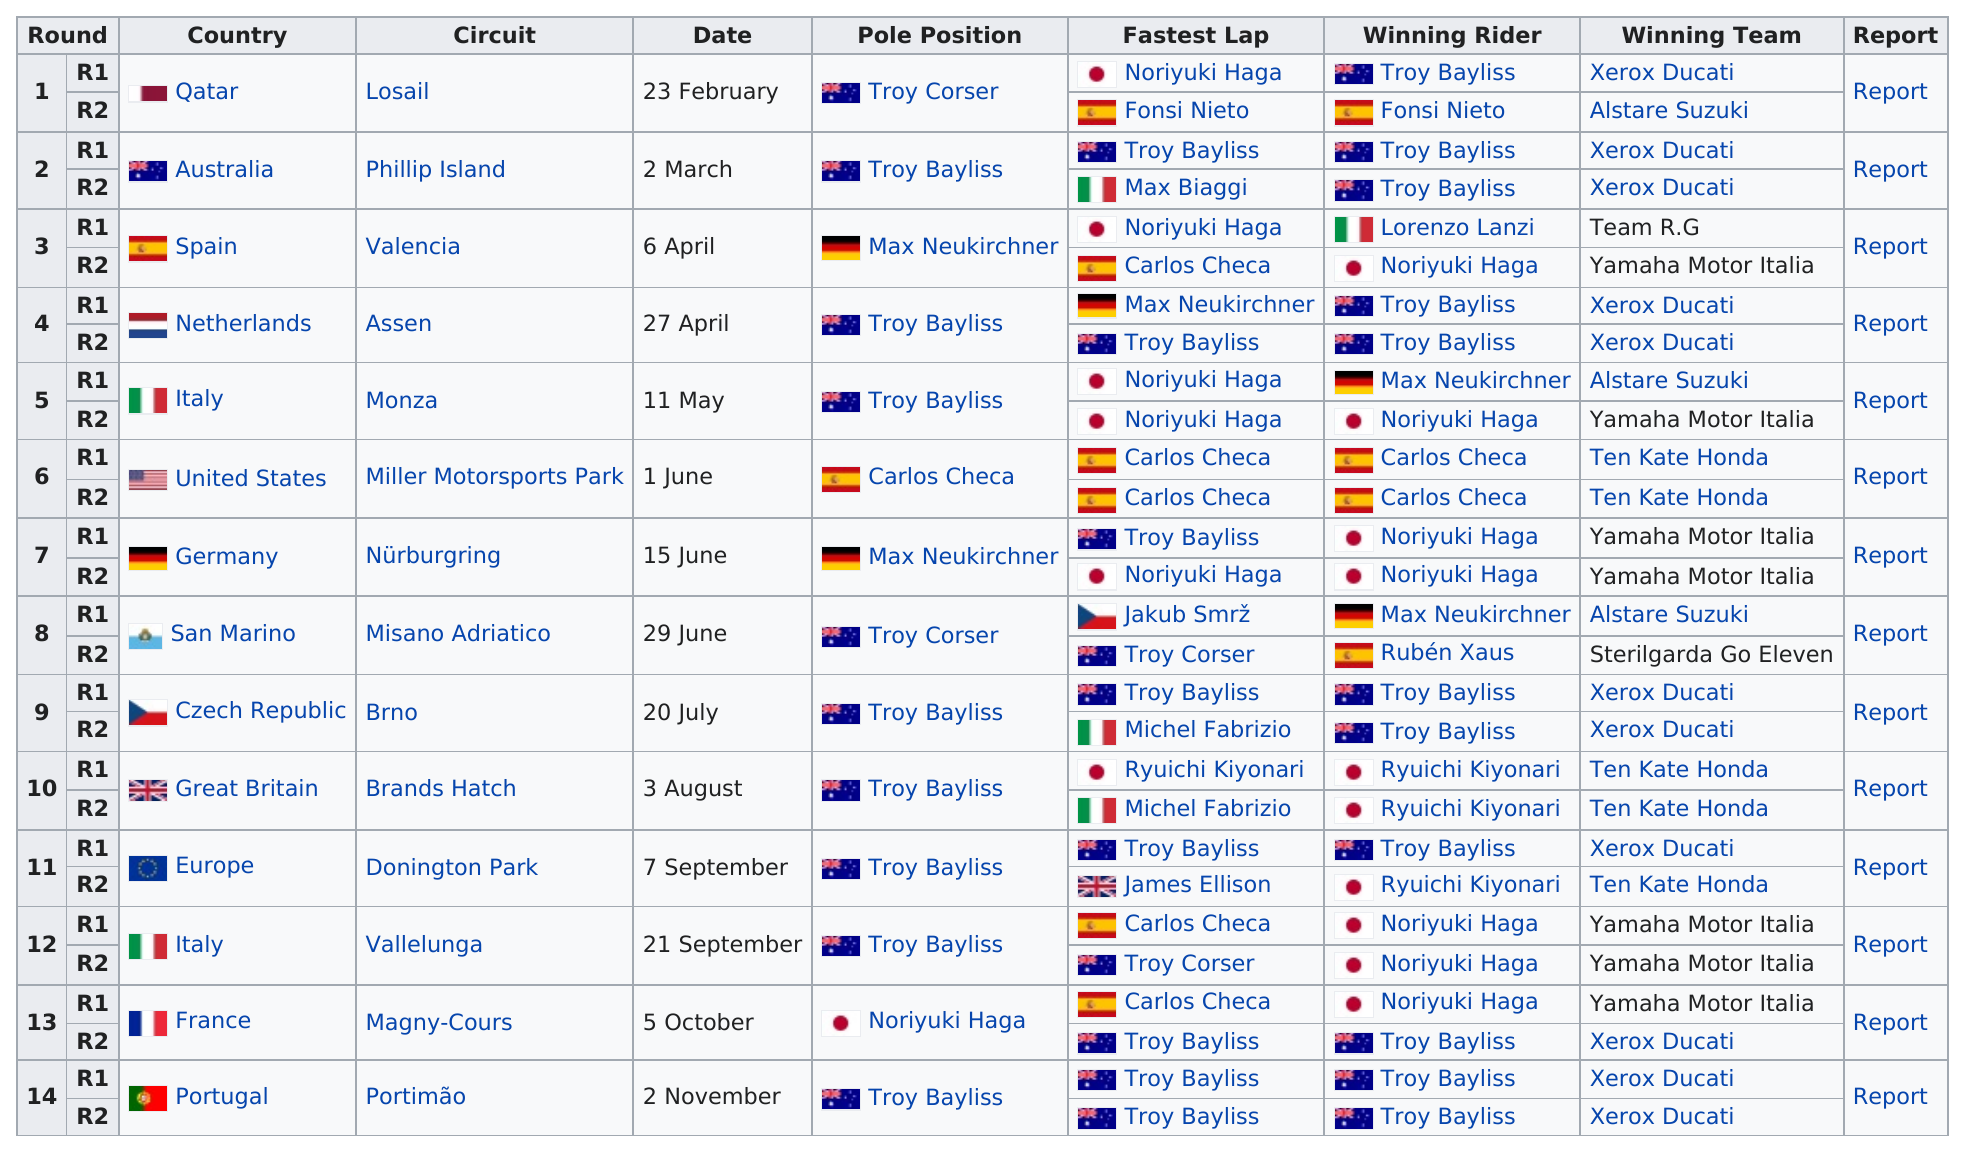Mention a couple of crucial points in this snapshot. Australia's riders have won more races than Germany's riders. Troy Bayliss won a total of 11 races. The last round of the season took place on 2 November. The Netherlands are next after Spain, and it is the fourth round. The last race of the season took place at Portimão. 